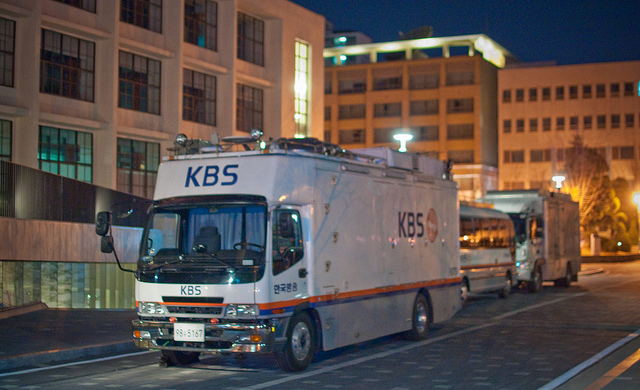Please transcribe the text information in this image. KBS KB5 KBS 